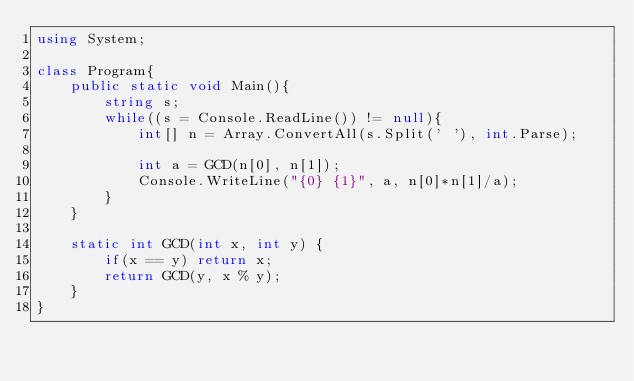Convert code to text. <code><loc_0><loc_0><loc_500><loc_500><_C#_>using System;
 
class Program{
	public static void Main(){
		string s;
		while((s = Console.ReadLine()) != null){
			int[] n = Array.ConvertAll(s.Split(' '), int.Parse);

			int a = GCD(n[0], n[1]);
			Console.WriteLine("{0} {1}", a, n[0]*n[1]/a);
		}
	}

	static int GCD(int x, int y) {
		if(x == y) return x;
		return GCD(y, x % y);
	}
}</code> 